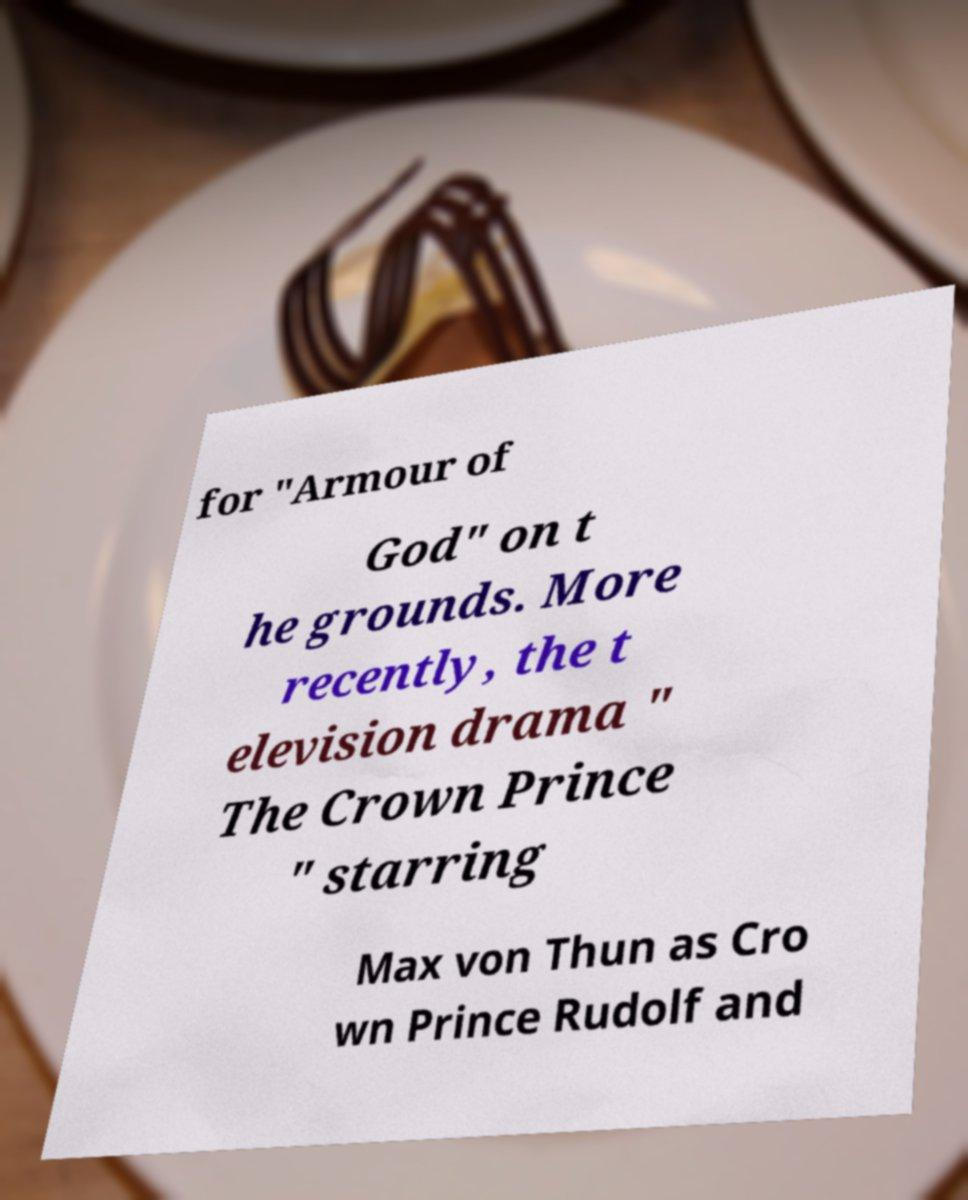There's text embedded in this image that I need extracted. Can you transcribe it verbatim? for "Armour of God" on t he grounds. More recently, the t elevision drama " The Crown Prince " starring Max von Thun as Cro wn Prince Rudolf and 